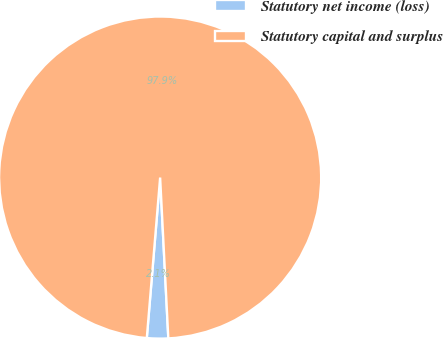<chart> <loc_0><loc_0><loc_500><loc_500><pie_chart><fcel>Statutory net income (loss)<fcel>Statutory capital and surplus<nl><fcel>2.13%<fcel>97.87%<nl></chart> 